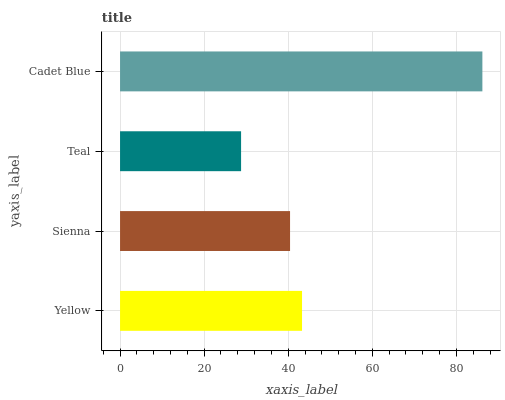Is Teal the minimum?
Answer yes or no. Yes. Is Cadet Blue the maximum?
Answer yes or no. Yes. Is Sienna the minimum?
Answer yes or no. No. Is Sienna the maximum?
Answer yes or no. No. Is Yellow greater than Sienna?
Answer yes or no. Yes. Is Sienna less than Yellow?
Answer yes or no. Yes. Is Sienna greater than Yellow?
Answer yes or no. No. Is Yellow less than Sienna?
Answer yes or no. No. Is Yellow the high median?
Answer yes or no. Yes. Is Sienna the low median?
Answer yes or no. Yes. Is Sienna the high median?
Answer yes or no. No. Is Teal the low median?
Answer yes or no. No. 